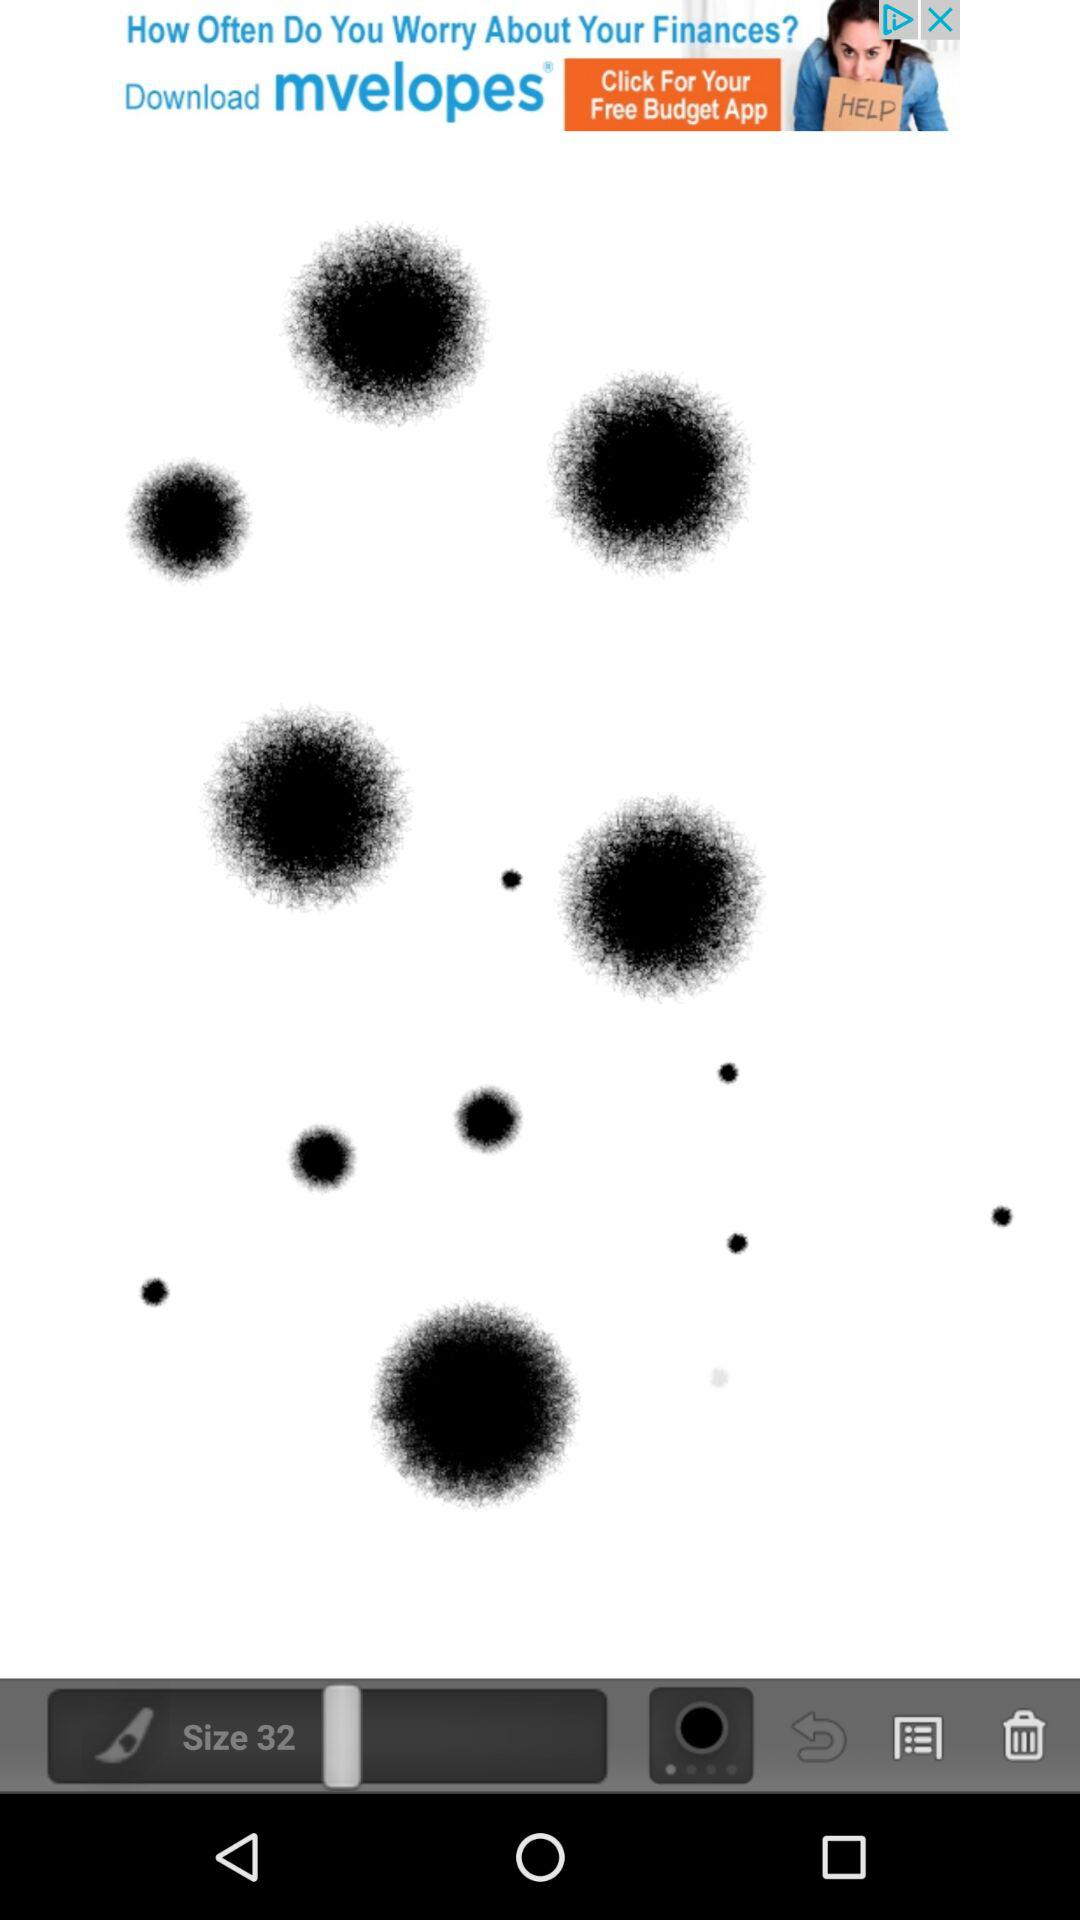What is the size? The size is 32. 